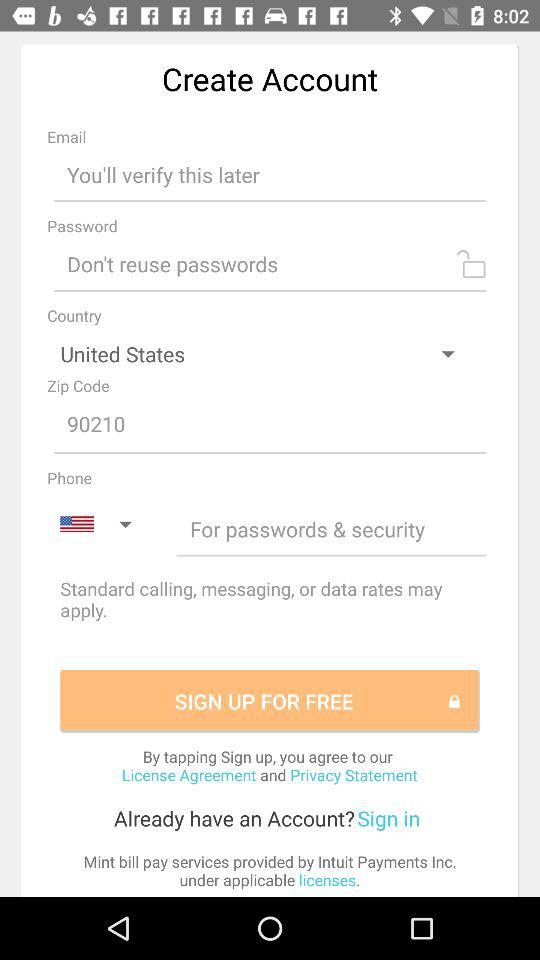What is the selected country? The selected country is the United States. 